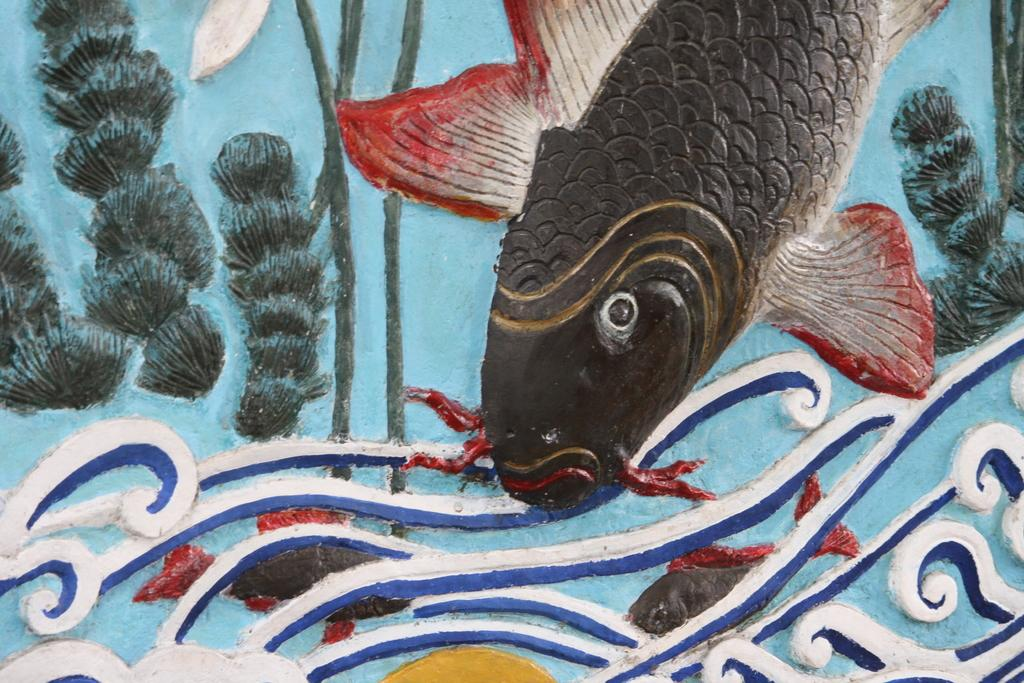What is depicted on the wall in the image? There is a painting on the wall in the image. What type of animals can be seen in the image? There are fishes in the image. Where is the monkey sitting in the image? There is no monkey present in the image. What color is the shirt worn by the fish in the image? Fish do not wear shirts, and there are no shirts depicted in the image. 